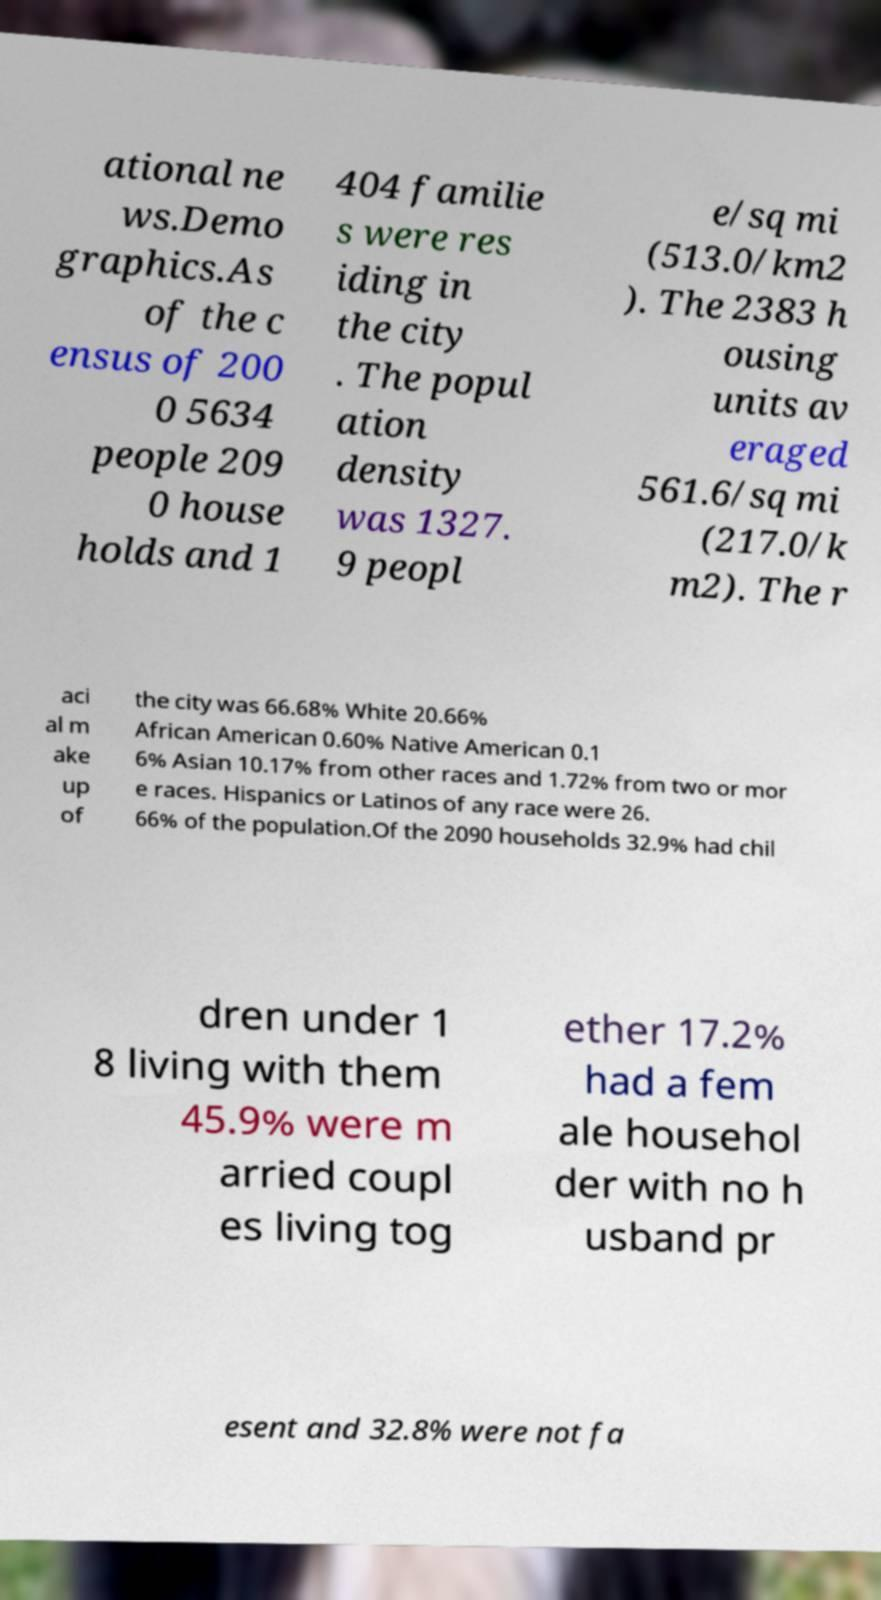Could you extract and type out the text from this image? ational ne ws.Demo graphics.As of the c ensus of 200 0 5634 people 209 0 house holds and 1 404 familie s were res iding in the city . The popul ation density was 1327. 9 peopl e/sq mi (513.0/km2 ). The 2383 h ousing units av eraged 561.6/sq mi (217.0/k m2). The r aci al m ake up of the city was 66.68% White 20.66% African American 0.60% Native American 0.1 6% Asian 10.17% from other races and 1.72% from two or mor e races. Hispanics or Latinos of any race were 26. 66% of the population.Of the 2090 households 32.9% had chil dren under 1 8 living with them 45.9% were m arried coupl es living tog ether 17.2% had a fem ale househol der with no h usband pr esent and 32.8% were not fa 